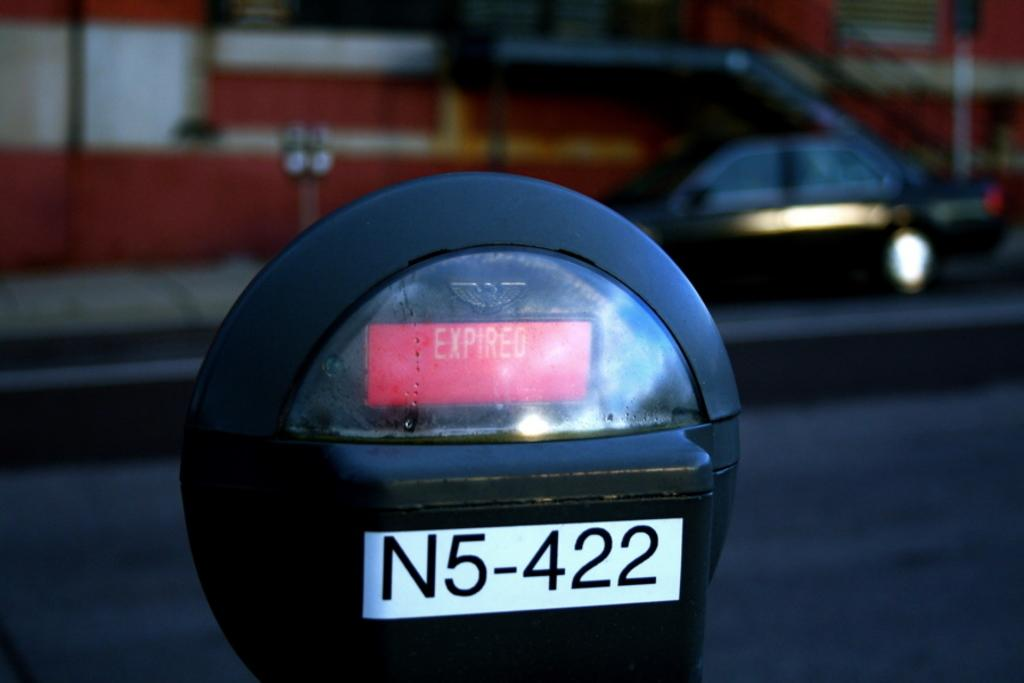<image>
Share a concise interpretation of the image provided. Black parking meter # N5-422 shows the time has expired. 